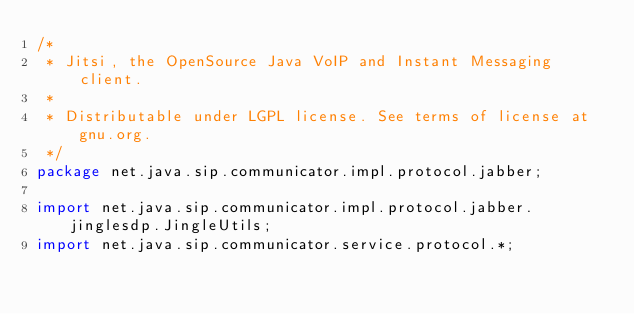<code> <loc_0><loc_0><loc_500><loc_500><_Java_>/*
 * Jitsi, the OpenSource Java VoIP and Instant Messaging client.
 *
 * Distributable under LGPL license. See terms of license at gnu.org.
 */
package net.java.sip.communicator.impl.protocol.jabber;

import net.java.sip.communicator.impl.protocol.jabber.jinglesdp.JingleUtils;
import net.java.sip.communicator.service.protocol.*;</code> 